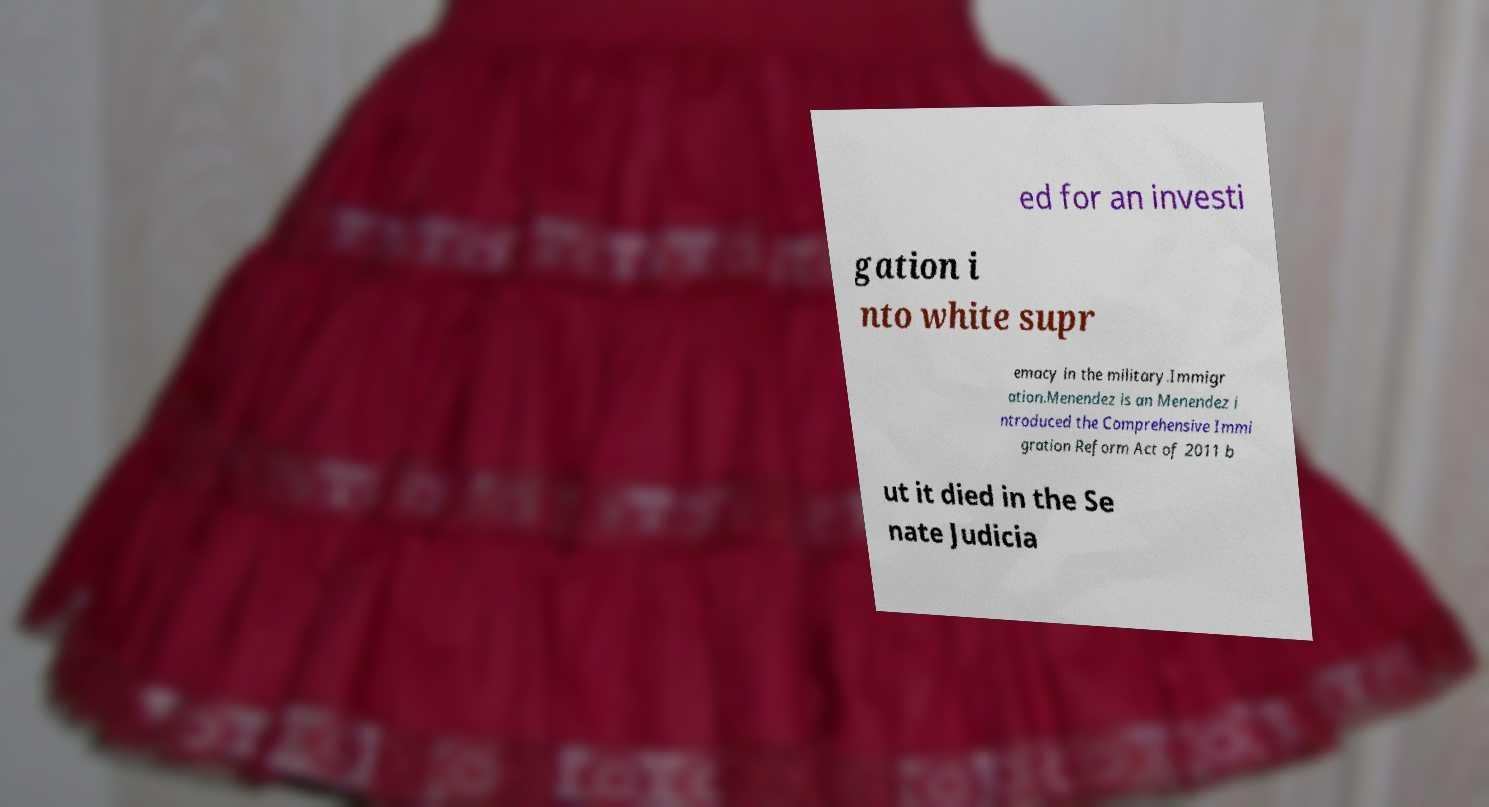Please identify and transcribe the text found in this image. ed for an investi gation i nto white supr emacy in the military.Immigr ation.Menendez is an Menendez i ntroduced the Comprehensive Immi gration Reform Act of 2011 b ut it died in the Se nate Judicia 